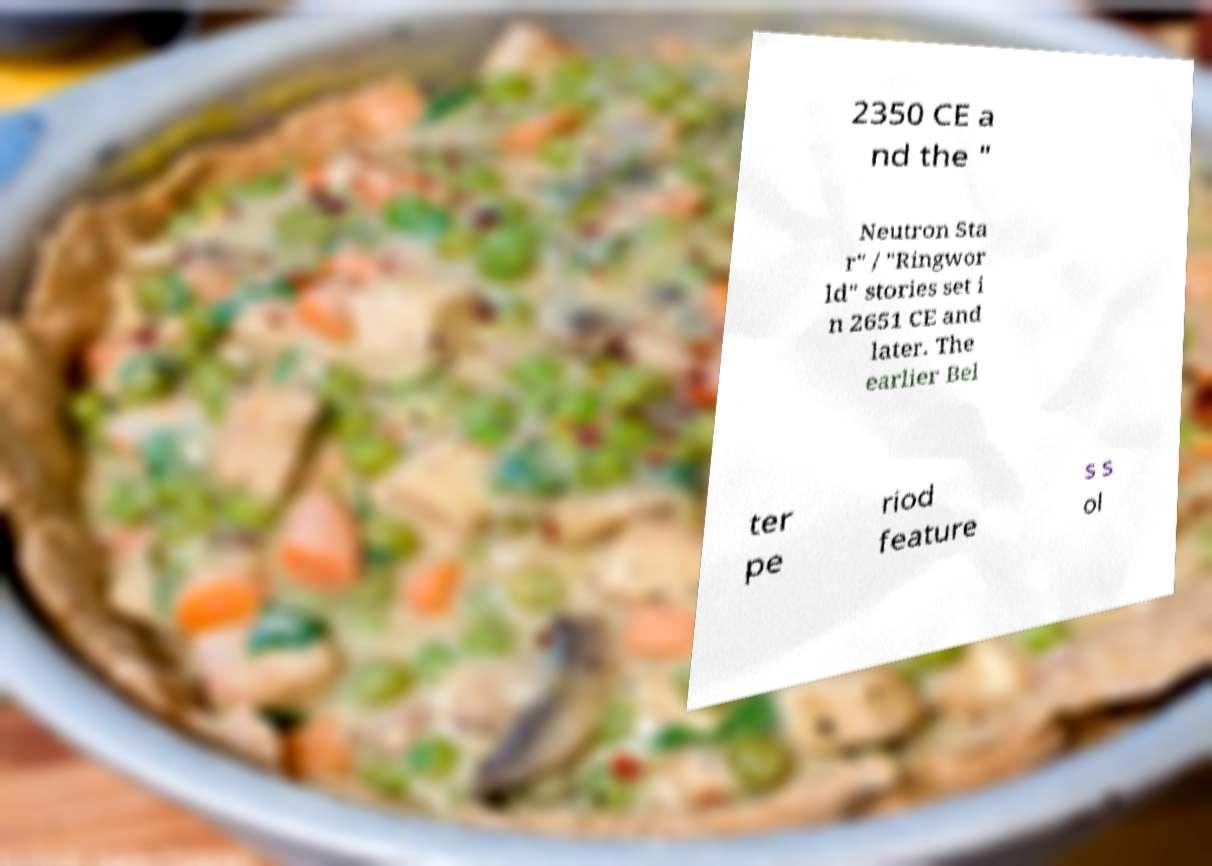Can you read and provide the text displayed in the image?This photo seems to have some interesting text. Can you extract and type it out for me? 2350 CE a nd the " Neutron Sta r" / "Ringwor ld" stories set i n 2651 CE and later. The earlier Bel ter pe riod feature s s ol 